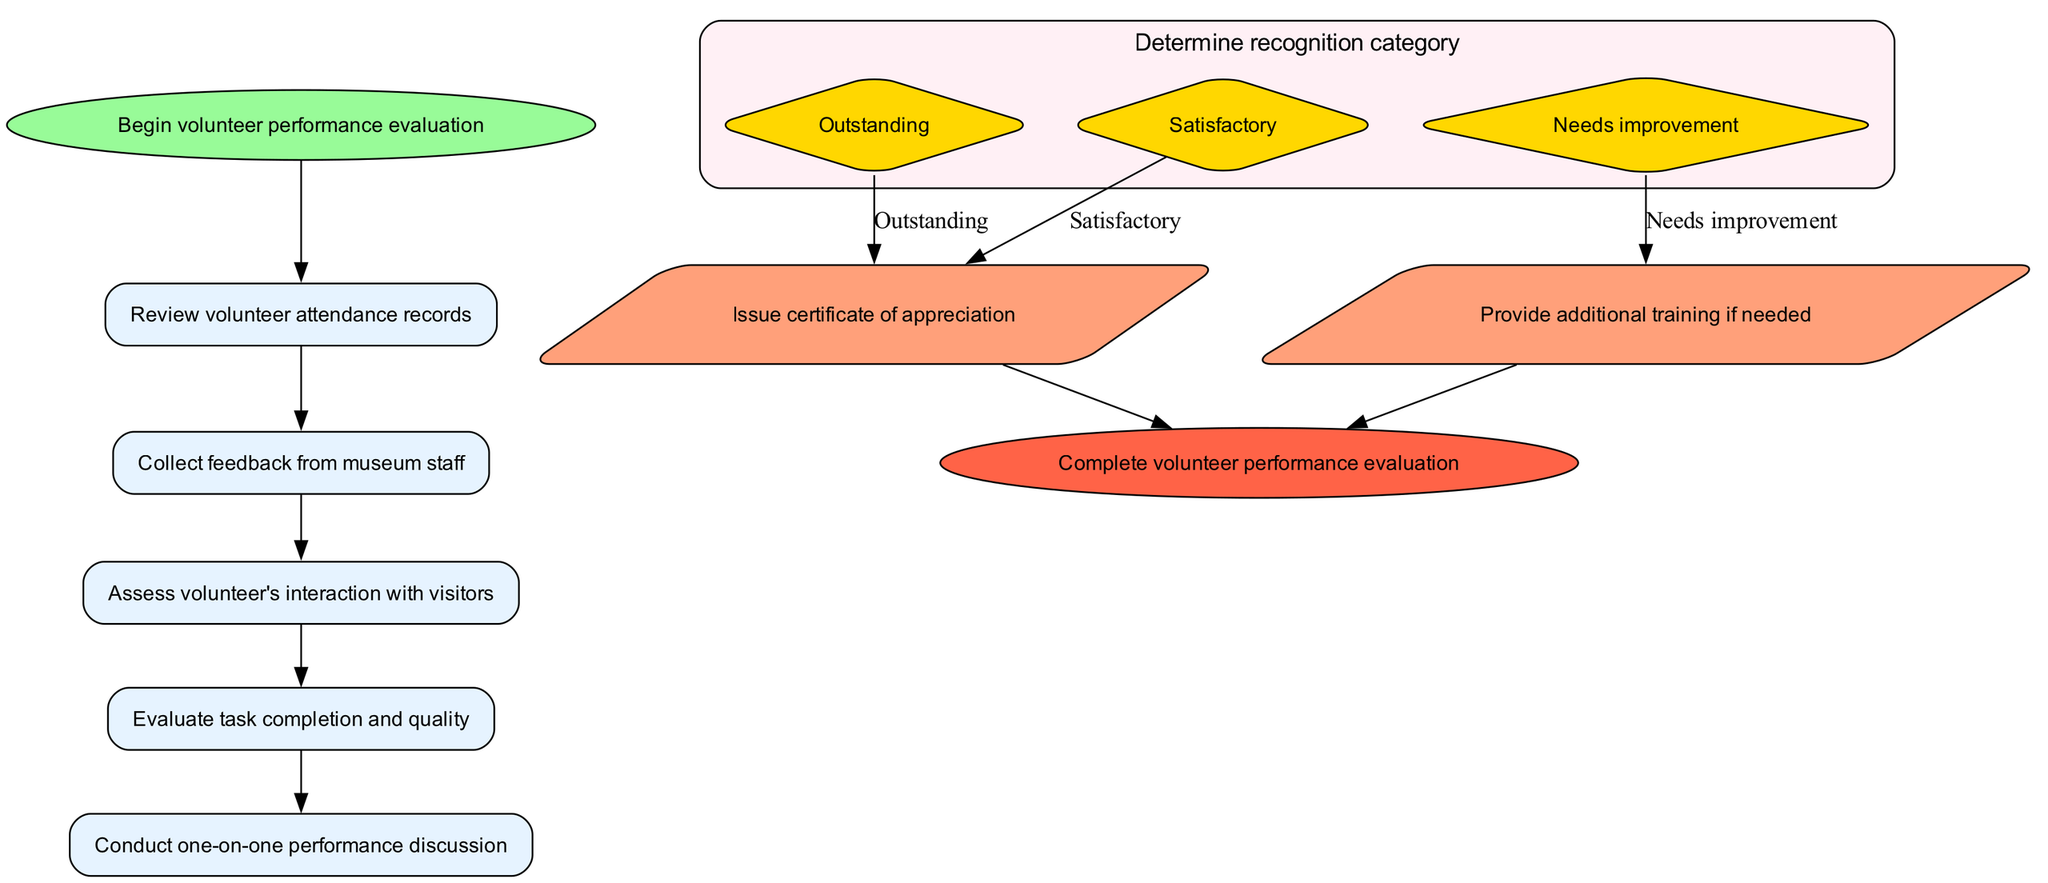What is the first step in the evaluation process? The diagram indicates that the first step in the evaluation process is to "Review volunteer attendance records."
Answer: Review volunteer attendance records How many options are there in the recognition category? There are three options listed in the recognition category: "Outstanding," "Satisfactory," and "Needs improvement."
Answer: Three What shape is used for the start node? The start node is represented with the shape of an oval.
Answer: Oval Which action follows the recognition of 'Outstanding'? According to the diagram, if a volunteer is recognized as 'Outstanding,' the next action is to "Issue certificate of appreciation."
Answer: Issue certificate of appreciation What node comes before the one-on-one performance discussion? The node that comes before "Conduct one-on-one performance discussion" is "Evaluate task completion and quality."
Answer: Evaluate task completion and quality If a volunteer's performance is deemed 'Needs improvement,' what action is taken? If the performance is classified as 'Needs improvement,' the action taken is to "Provide additional training if needed."
Answer: Provide additional training if needed How many edges connect the steps directly one after another? The diagram shows four edges connecting the steps directly one after another without any options.
Answer: Four What happens at the end of the evaluation process? The end of the evaluation process is marked by completing the volunteer performance evaluation, as shown in the last node.
Answer: Complete volunteer performance evaluation 